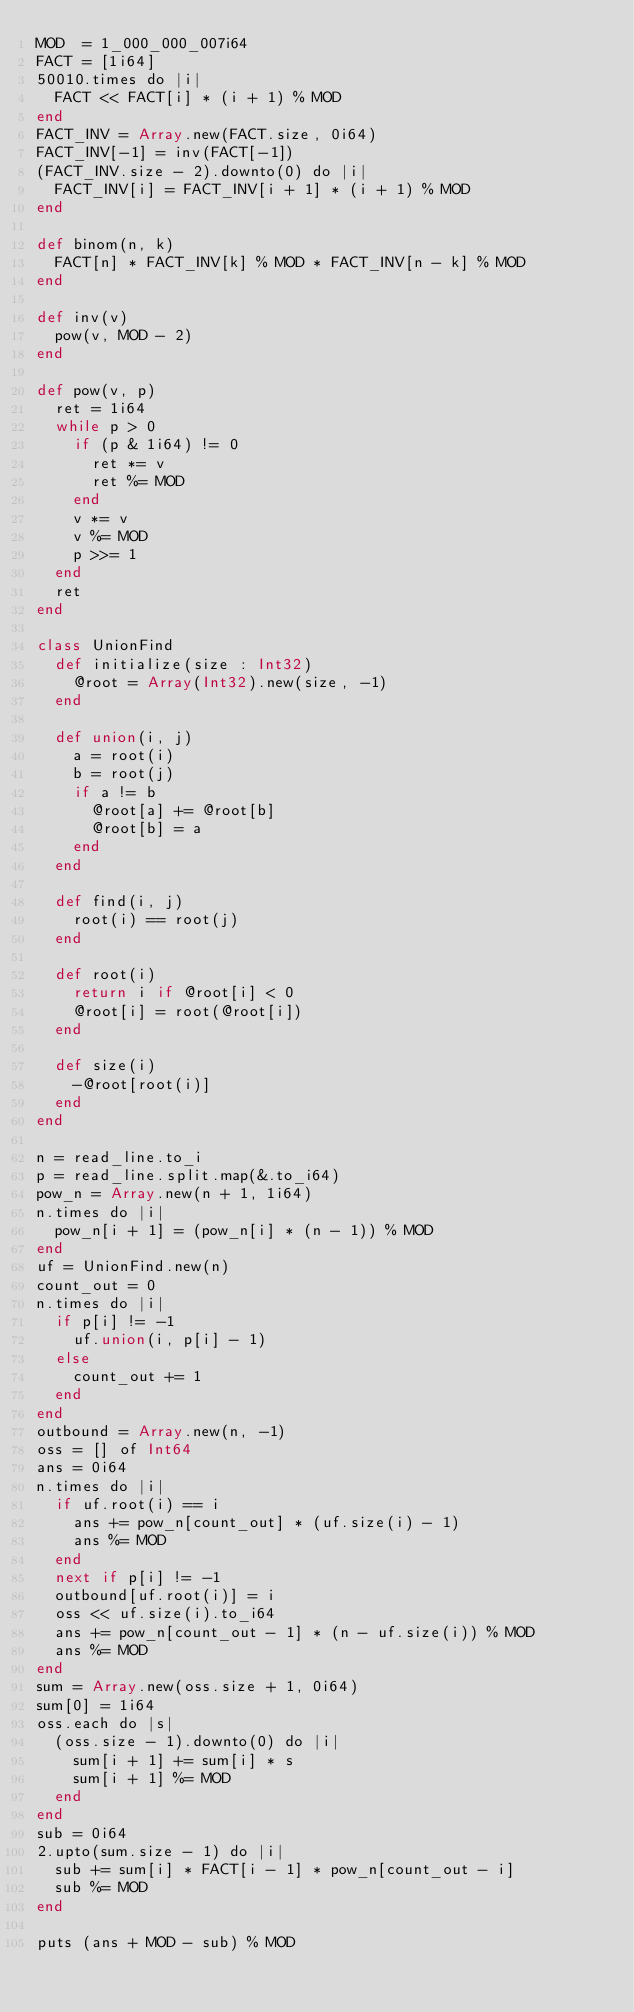<code> <loc_0><loc_0><loc_500><loc_500><_Crystal_>MOD  = 1_000_000_007i64
FACT = [1i64]
50010.times do |i|
  FACT << FACT[i] * (i + 1) % MOD
end
FACT_INV = Array.new(FACT.size, 0i64)
FACT_INV[-1] = inv(FACT[-1])
(FACT_INV.size - 2).downto(0) do |i|
  FACT_INV[i] = FACT_INV[i + 1] * (i + 1) % MOD
end

def binom(n, k)
  FACT[n] * FACT_INV[k] % MOD * FACT_INV[n - k] % MOD
end

def inv(v)
  pow(v, MOD - 2)
end

def pow(v, p)
  ret = 1i64
  while p > 0
    if (p & 1i64) != 0
      ret *= v
      ret %= MOD
    end
    v *= v
    v %= MOD
    p >>= 1
  end
  ret
end

class UnionFind
  def initialize(size : Int32)
    @root = Array(Int32).new(size, -1)
  end

  def union(i, j)
    a = root(i)
    b = root(j)
    if a != b
      @root[a] += @root[b]
      @root[b] = a
    end
  end

  def find(i, j)
    root(i) == root(j)
  end

  def root(i)
    return i if @root[i] < 0
    @root[i] = root(@root[i])
  end

  def size(i)
    -@root[root(i)]
  end
end

n = read_line.to_i
p = read_line.split.map(&.to_i64)
pow_n = Array.new(n + 1, 1i64)
n.times do |i|
  pow_n[i + 1] = (pow_n[i] * (n - 1)) % MOD
end
uf = UnionFind.new(n)
count_out = 0
n.times do |i|
  if p[i] != -1
    uf.union(i, p[i] - 1)
  else
    count_out += 1
  end
end
outbound = Array.new(n, -1)
oss = [] of Int64
ans = 0i64
n.times do |i|
  if uf.root(i) == i
    ans += pow_n[count_out] * (uf.size(i) - 1)
    ans %= MOD
  end
  next if p[i] != -1
  outbound[uf.root(i)] = i
  oss << uf.size(i).to_i64
  ans += pow_n[count_out - 1] * (n - uf.size(i)) % MOD
  ans %= MOD
end
sum = Array.new(oss.size + 1, 0i64)
sum[0] = 1i64
oss.each do |s|
  (oss.size - 1).downto(0) do |i|
    sum[i + 1] += sum[i] * s
    sum[i + 1] %= MOD
  end
end
sub = 0i64
2.upto(sum.size - 1) do |i|
  sub += sum[i] * FACT[i - 1] * pow_n[count_out - i]
  sub %= MOD
end

puts (ans + MOD - sub) % MOD
</code> 